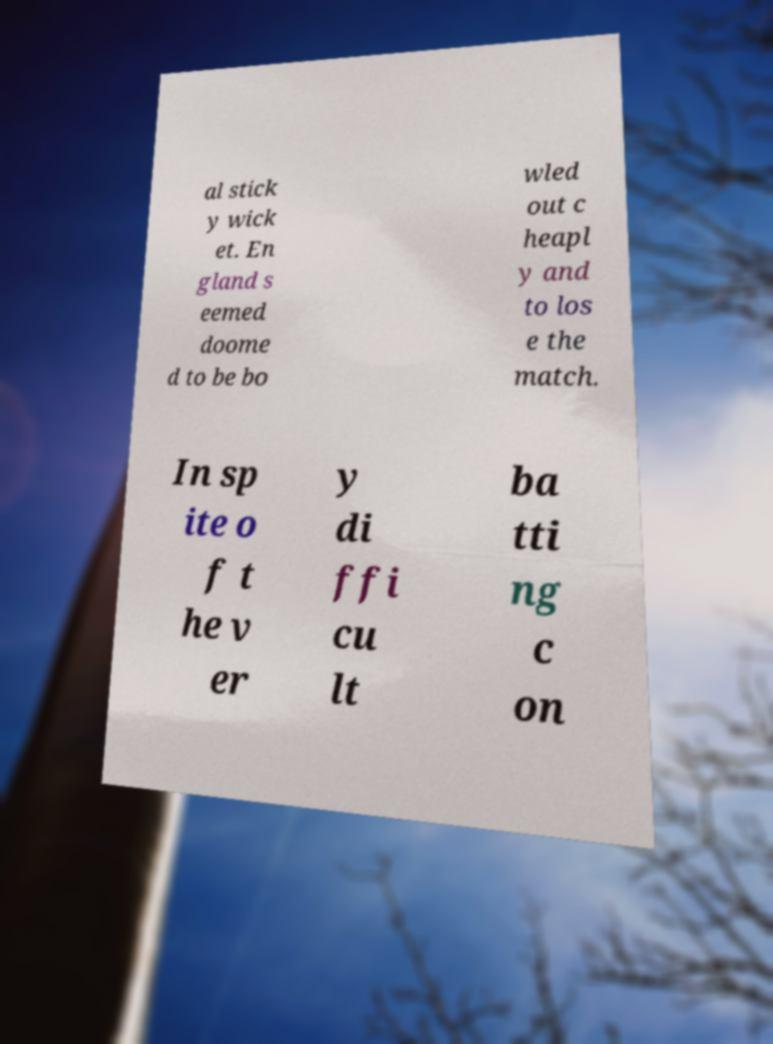Can you read and provide the text displayed in the image?This photo seems to have some interesting text. Can you extract and type it out for me? al stick y wick et. En gland s eemed doome d to be bo wled out c heapl y and to los e the match. In sp ite o f t he v er y di ffi cu lt ba tti ng c on 